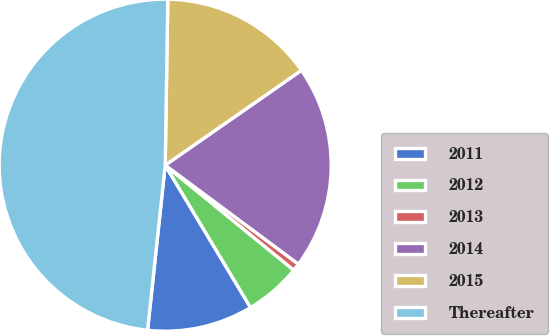<chart> <loc_0><loc_0><loc_500><loc_500><pie_chart><fcel>2011<fcel>2012<fcel>2013<fcel>2014<fcel>2015<fcel>Thereafter<nl><fcel>10.29%<fcel>5.51%<fcel>0.73%<fcel>19.85%<fcel>15.07%<fcel>48.55%<nl></chart> 